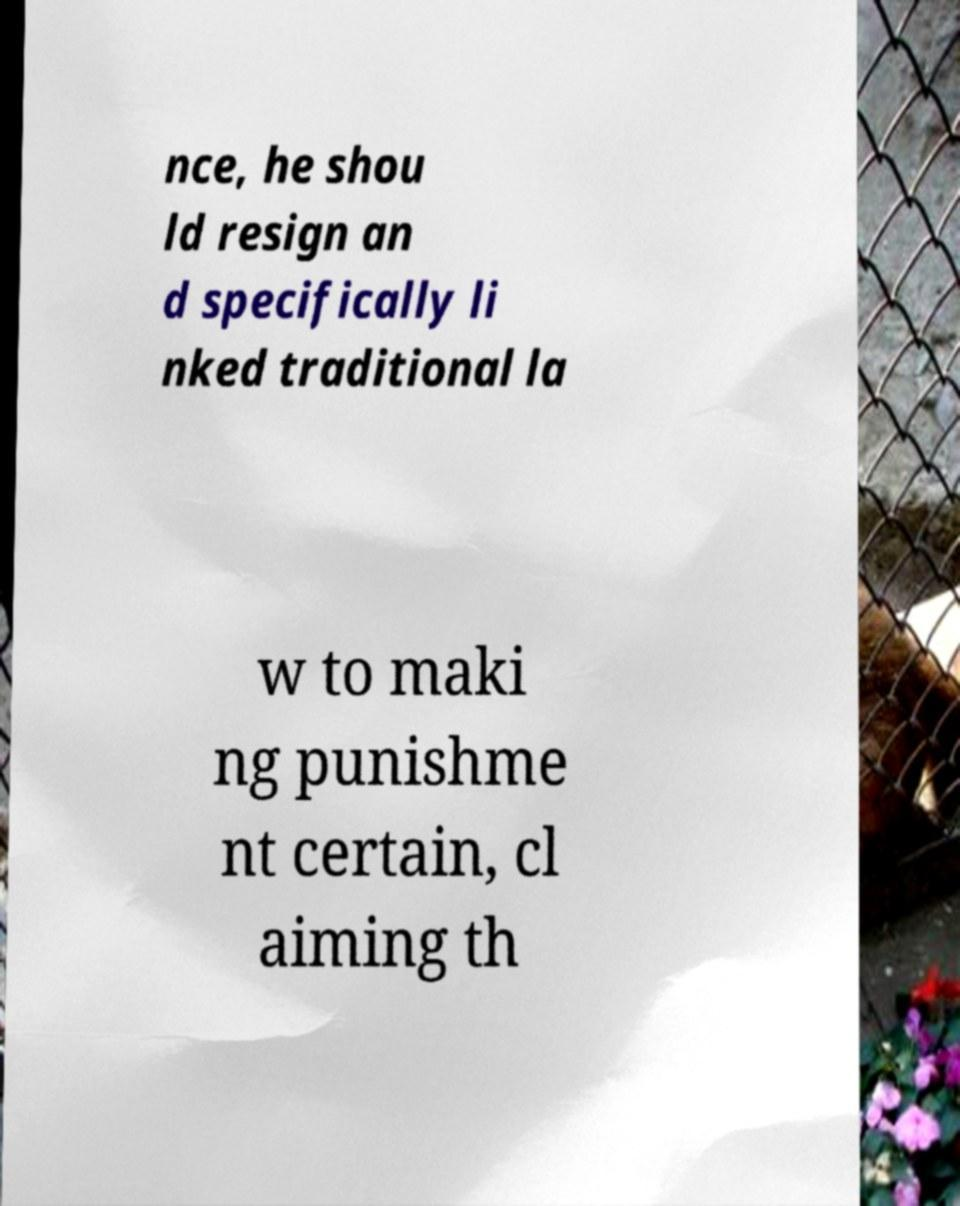What messages or text are displayed in this image? I need them in a readable, typed format. nce, he shou ld resign an d specifically li nked traditional la w to maki ng punishme nt certain, cl aiming th 